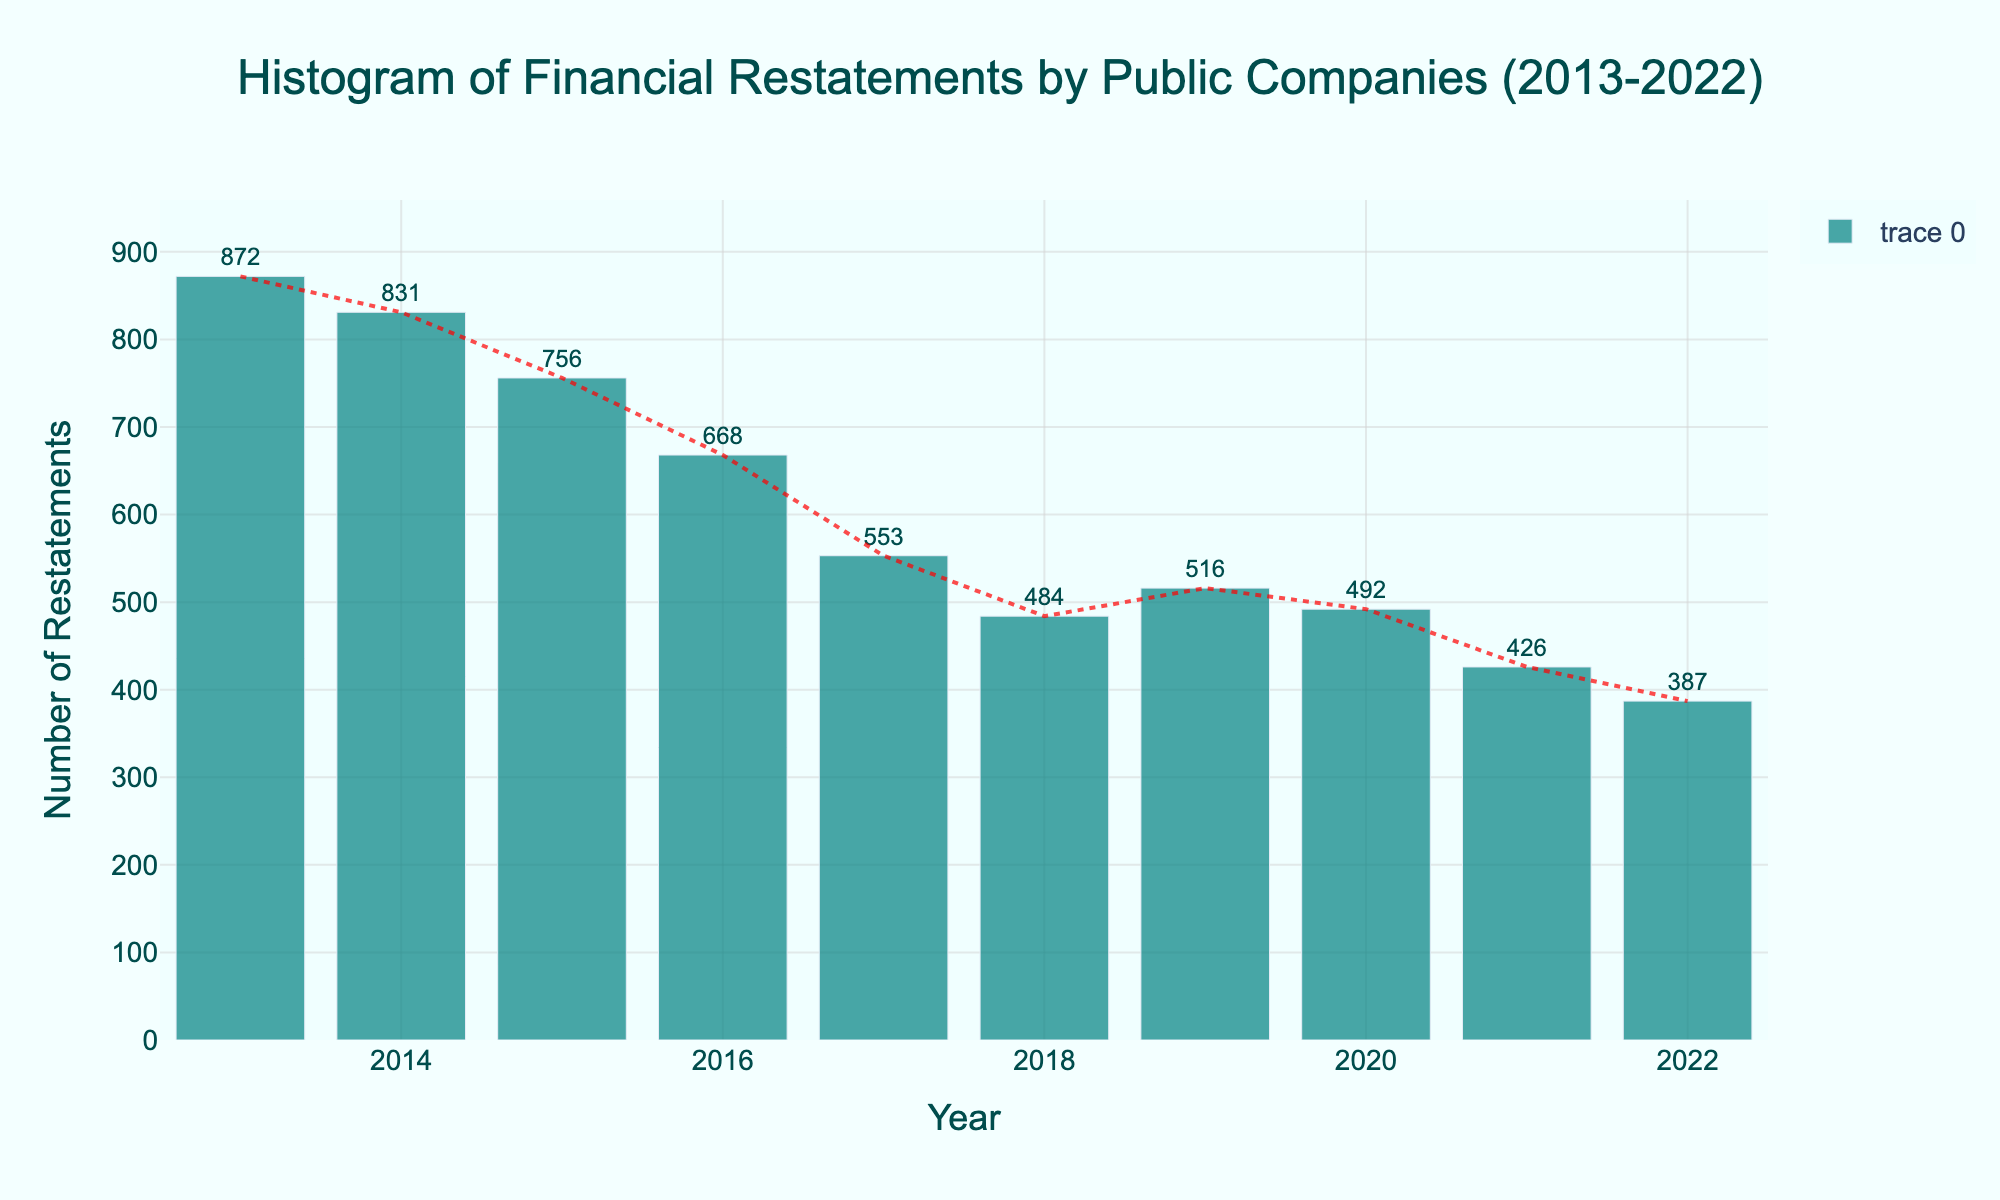What is the title of the histogram? The title is located at the top of the figure and provides a summary of what the histogram represents. It reads: "Histogram of Financial Restatements by Public Companies (2013-2022)"
Answer: Histogram of Financial Restatements by Public Companies (2013-2022) Which year had the highest number of financial restatements? By looking at the heights of the bars, we can identify the tallest bar corresponding to the year 2013.
Answer: 2013 How many financial restatements were recorded in 2017? Check the height of the bar corresponding to the year 2017 and read the value on the text shown above the bar.
Answer: 553 What is the trend of financial restatements over the decade? Observe the trend line added to the histogram, which overall shows a downward (declining) pattern.
Answer: Declining Which two consecutive years showed an increase in the number of financial restatements? Compare the heights of the bars year by year to see where an increase is observed. From 2018 to 2019, the number of restatements increased.
Answer: 2018 and 2019 What is the average number of financial restatements per year over this period? Add up the numbers for each year and divide by the number of years (10): (872+831+756+668+553+484+516+492+426+387)/10 = 5385/10 = 538.5
Answer: 538.5 How does the number of restatements in 2020 compare to the number in 2022? Compare the height of the bars for 2020 and 2022. 2020 has a higher value (492) than 2022 (387).
Answer: 2020 has more restatements than 2022 By how much did the number of financial restatements decrease from 2013 to 2022? Subtract the number of restatements in 2022 from those in 2013: 872 - 387 = 485
Answer: 485 Which year had the lowest number of financial restatements? Identify the shortest bar in the histogram, which corresponds to the year 2022.
Answer: 2022 What is the total number of financial restatements over the decade? Sum the values for each year: 872 + 831 + 756 + 668 + 553 + 484 + 516 + 492 + 426 + 387 = 5385
Answer: 5385 